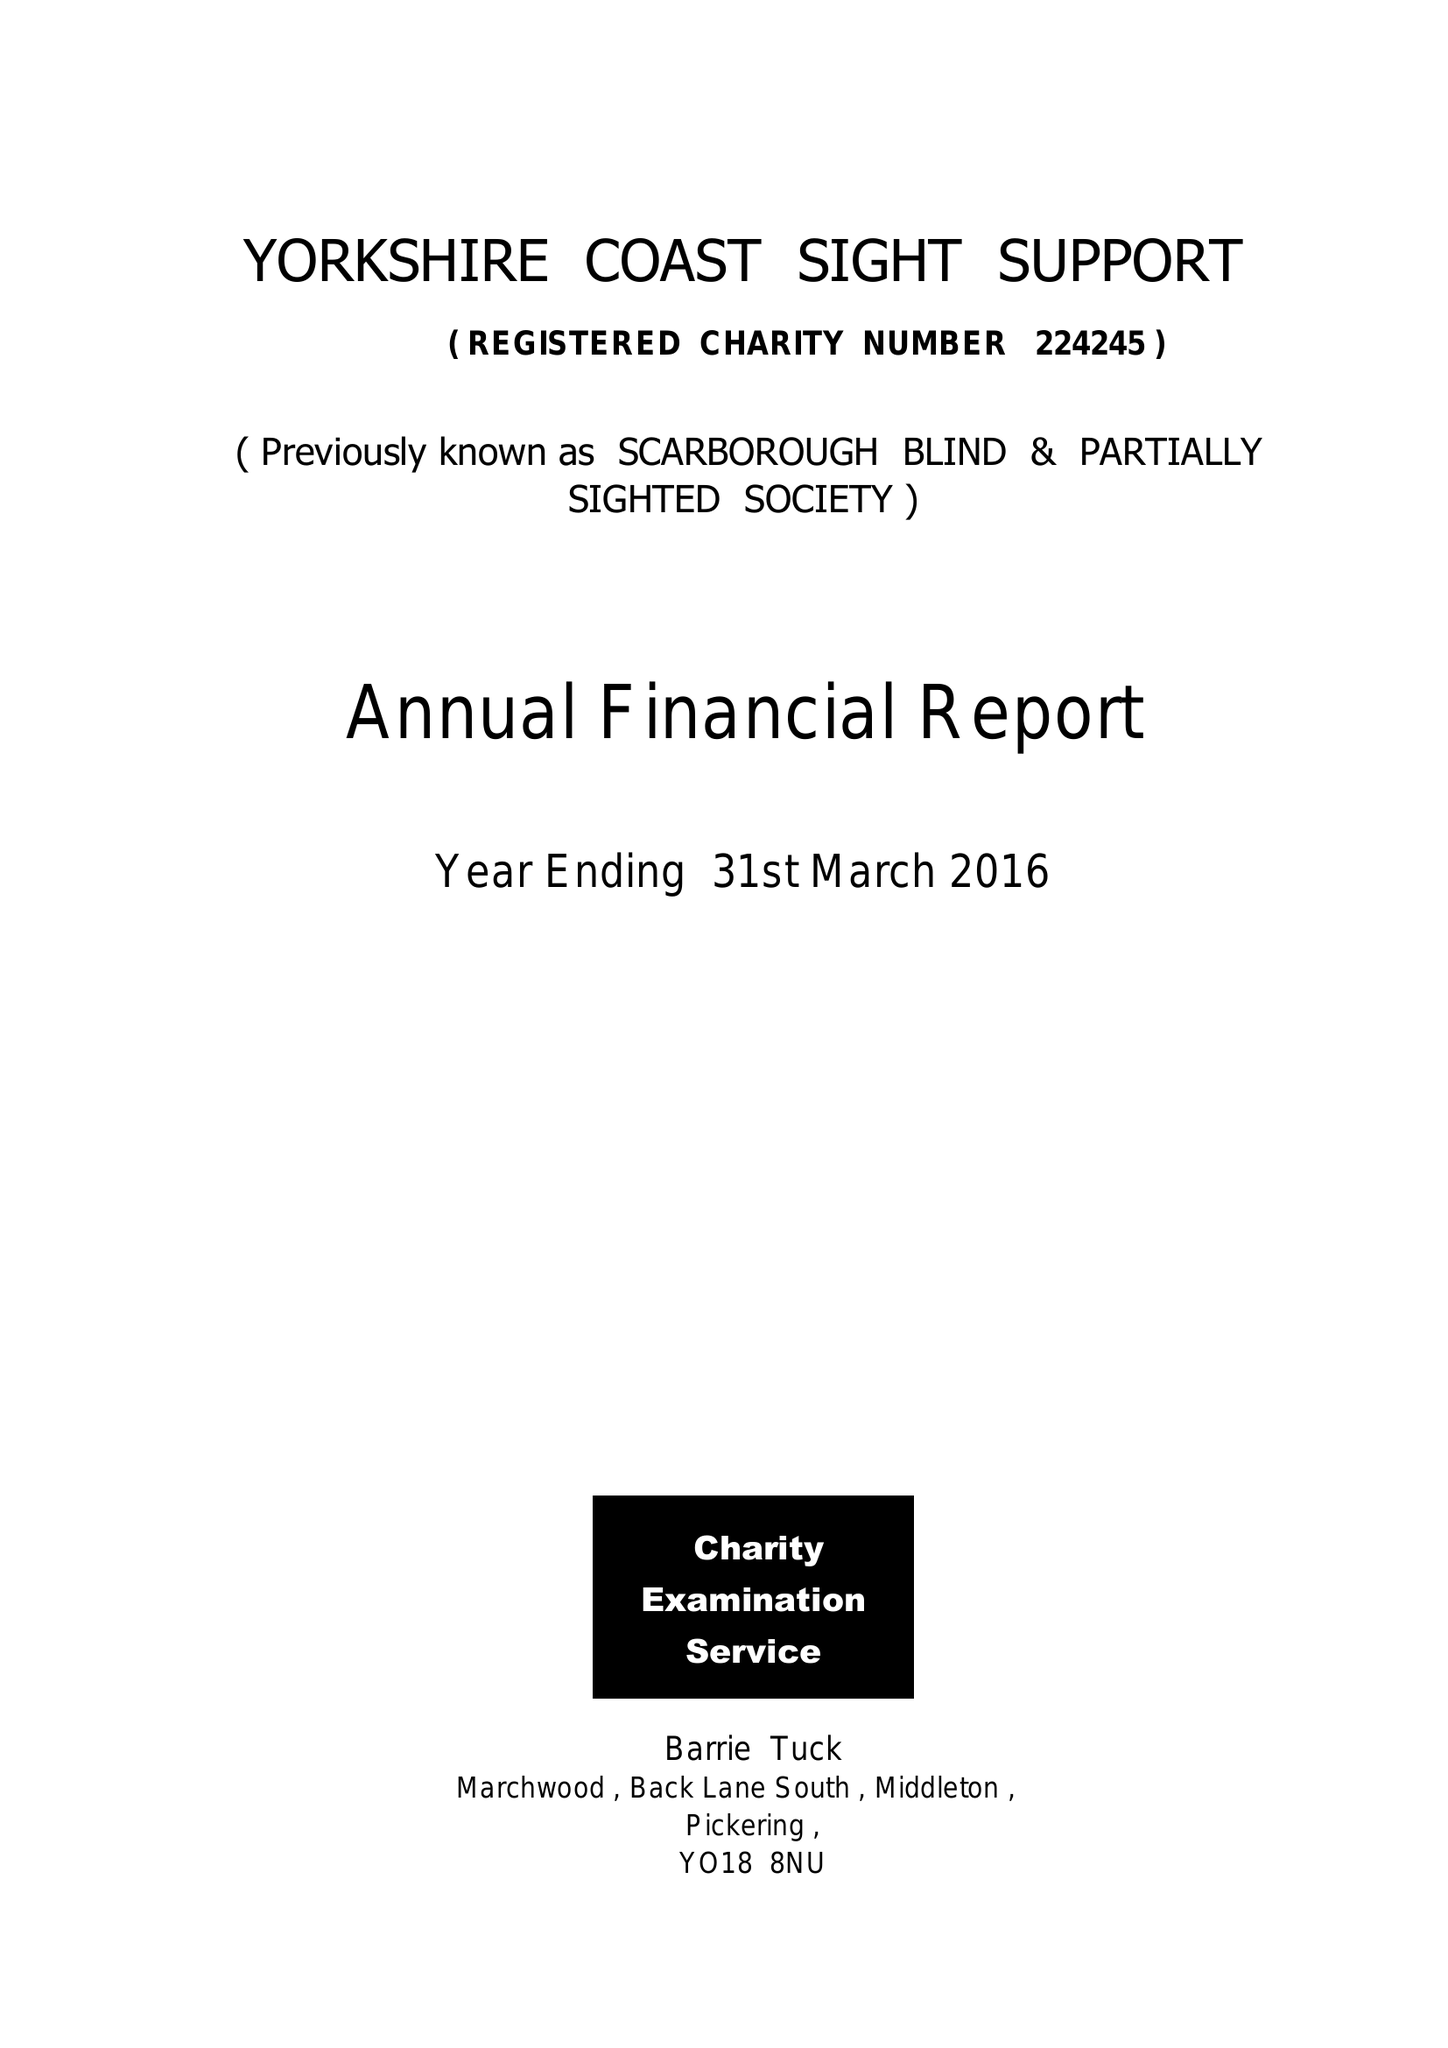What is the value for the report_date?
Answer the question using a single word or phrase. 2016-03-31 